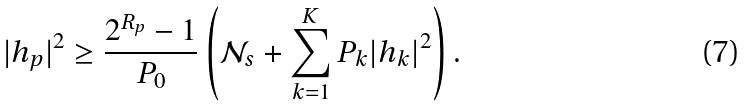<formula> <loc_0><loc_0><loc_500><loc_500>| h _ { p } | ^ { 2 } \geq \frac { 2 ^ { R _ { p } } - 1 } { P _ { 0 } } \left ( \mathcal { N } _ { s } + \sum _ { k = 1 } ^ { K } P _ { k } | h _ { k } | ^ { 2 } \right ) .</formula> 